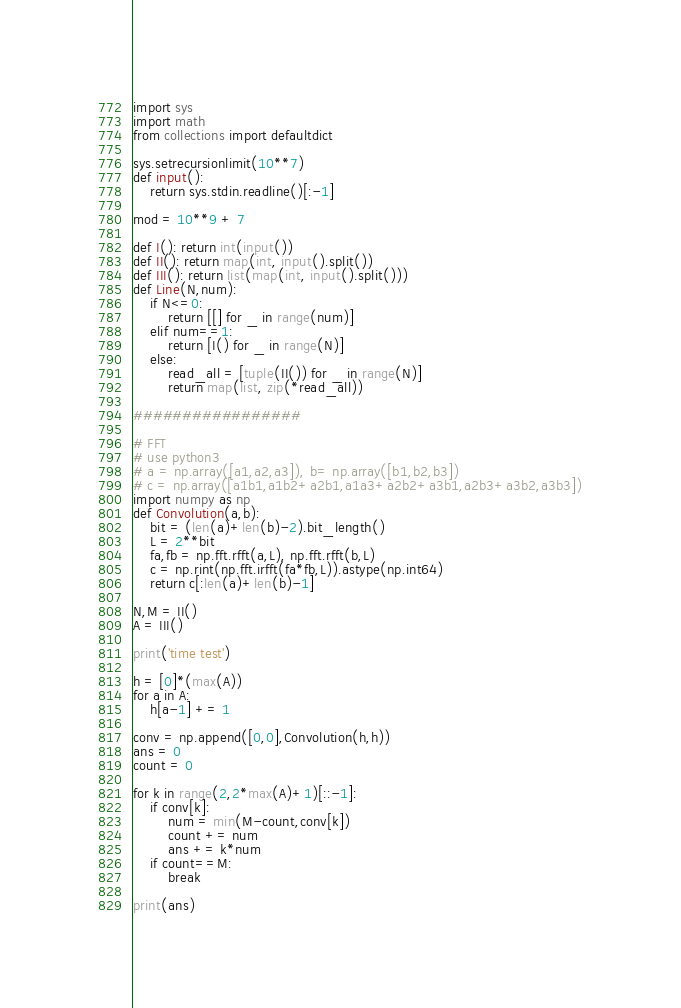Convert code to text. <code><loc_0><loc_0><loc_500><loc_500><_Python_>import sys
import math
from collections import defaultdict

sys.setrecursionlimit(10**7)
def input():
    return sys.stdin.readline()[:-1]

mod = 10**9 + 7

def I(): return int(input())
def II(): return map(int, input().split())
def III(): return list(map(int, input().split()))
def Line(N,num):
    if N<=0:
        return [[] for _ in range(num)]
    elif num==1:
        return [I() for _ in range(N)]
    else:
        read_all = [tuple(II()) for _ in range(N)]
        return map(list, zip(*read_all))

#################

# FFT
# use python3
# a = np.array([a1,a2,a3]), b= np.array([b1,b2,b3])
# c = np.array([a1b1,a1b2+a2b1,a1a3+a2b2+a3b1,a2b3+a3b2,a3b3])
import numpy as np
def Convolution(a,b):
    bit = (len(a)+len(b)-2).bit_length()
    L = 2**bit
    fa,fb = np.fft.rfft(a,L), np.fft.rfft(b,L)
    c = np.rint(np.fft.irfft(fa*fb,L)).astype(np.int64)
    return c[:len(a)+len(b)-1]

N,M = II()
A = III()

print('time test')

h = [0]*(max(A))
for a in A:
    h[a-1] += 1

conv = np.append([0,0],Convolution(h,h))
ans = 0
count = 0

for k in range(2,2*max(A)+1)[::-1]:
    if conv[k]:
        num = min(M-count,conv[k])
        count += num
        ans += k*num
    if count==M:
        break

print(ans)</code> 